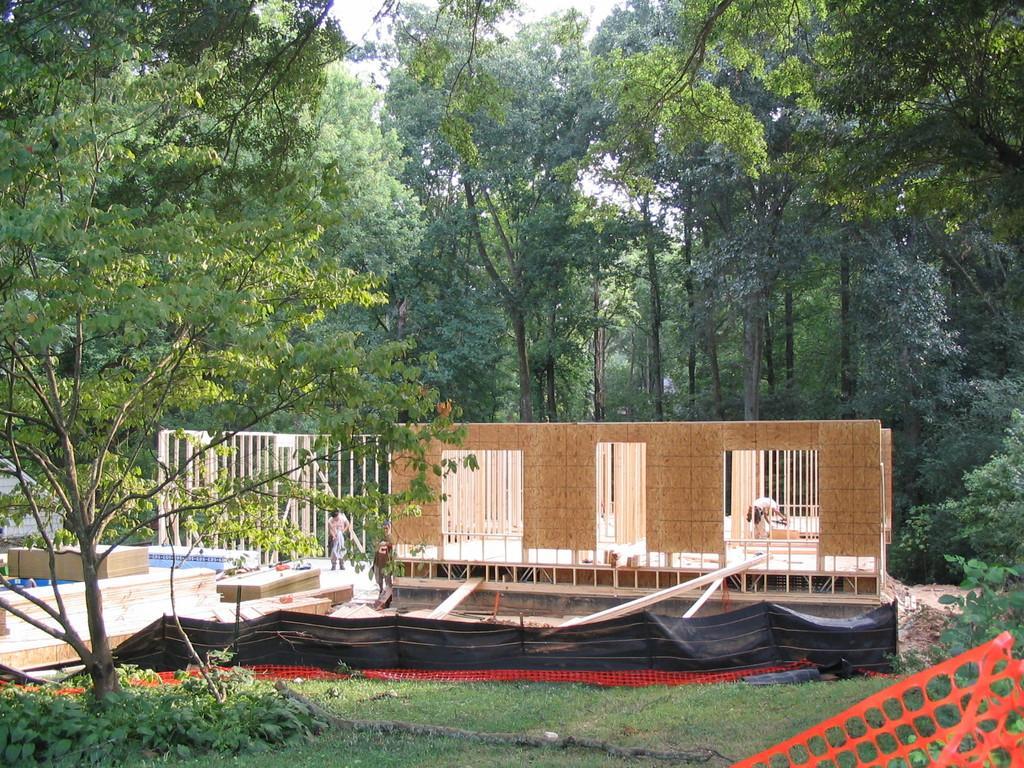Please provide a concise description of this image. On the left side, there are a tree and plants on the ground. On the right side, there are an orange color fence and plants. In the background, there are three persons constructing a building, there are trees and there is sky. 